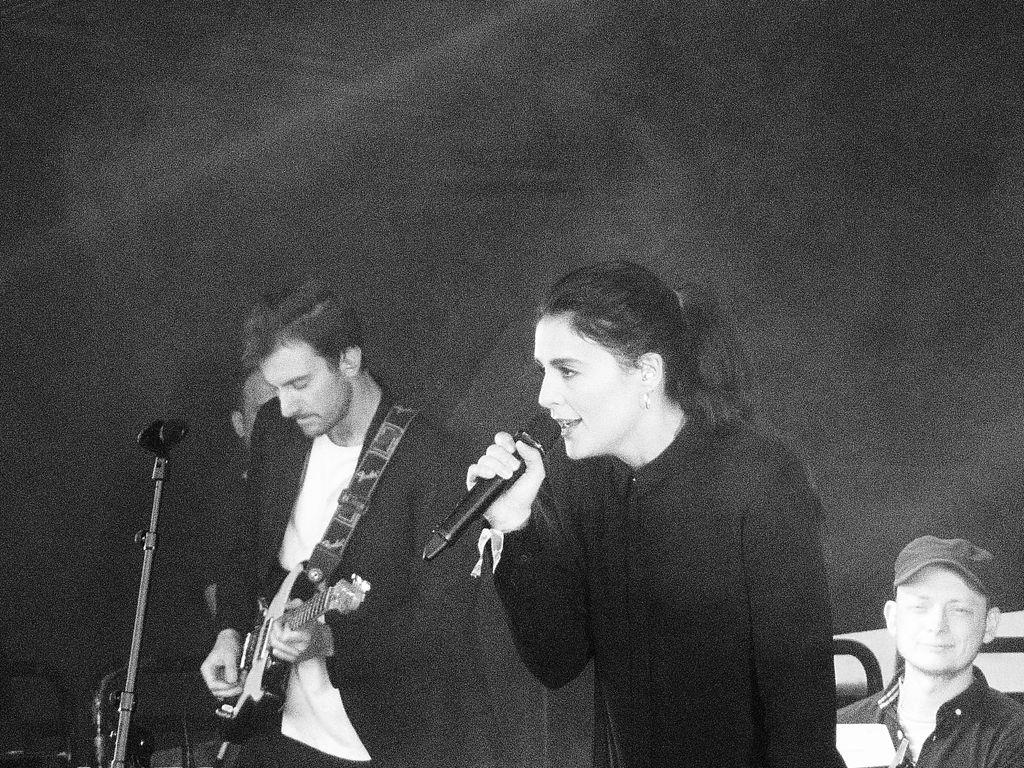How many people are in the image? There are people in the image. What are the people doing in the image? One person is holding a guitar, one person is holding a microphone, and one person is wearing a cap. Can you describe the person holding the guitar? The person holding the guitar is one of the people in the image. What is the person holding the microphone wearing? The person holding the microphone is one of the people in the image, but the provided facts do not mention their clothing. How many dimes are on the floor near the person holding the microphone? There is no mention of dimes in the image, so we cannot determine their presence or quantity. What type of throat lozenges is the person holding the microphone using? There is no mention of throat lozenges or any medical items in the image, so we cannot determine their presence or use. 